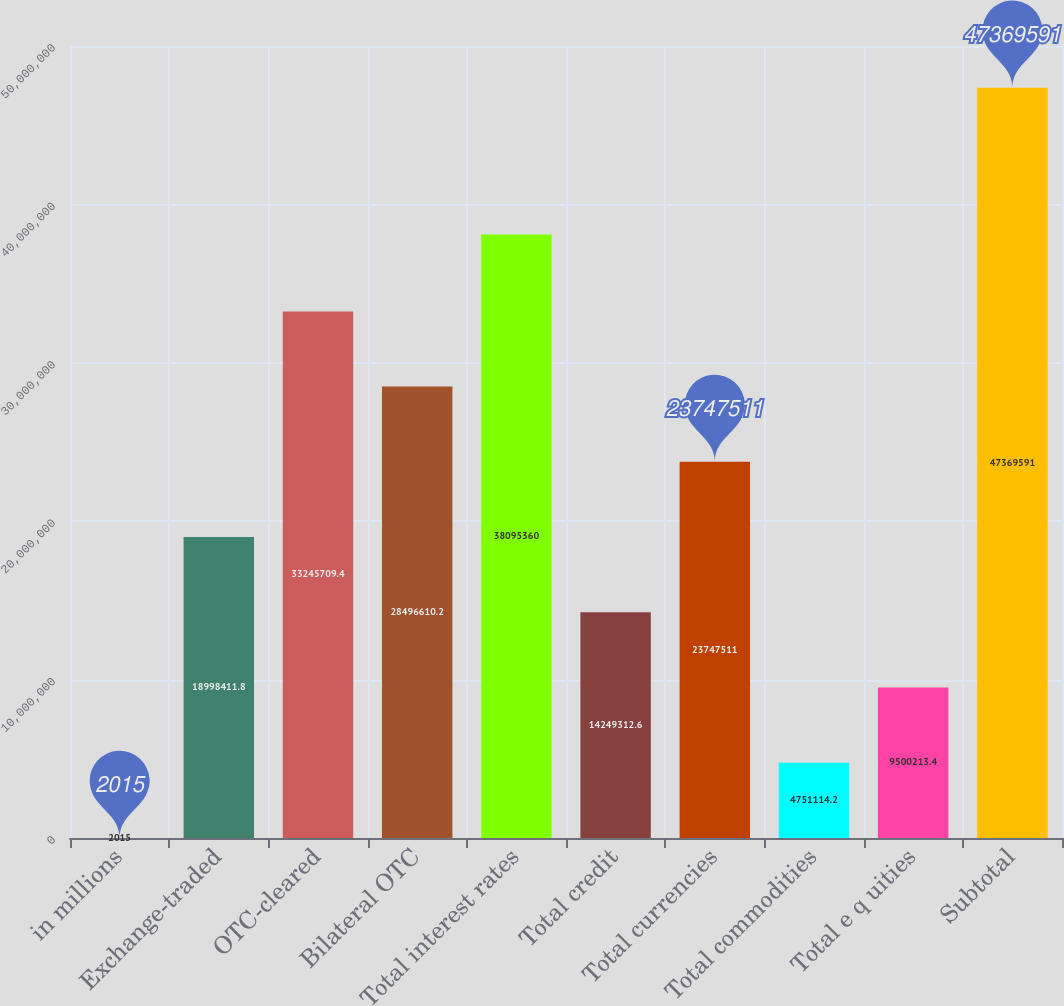<chart> <loc_0><loc_0><loc_500><loc_500><bar_chart><fcel>in millions<fcel>Exchange-traded<fcel>OTC-cleared<fcel>Bilateral OTC<fcel>Total interest rates<fcel>Total credit<fcel>Total currencies<fcel>Total commodities<fcel>Total e q uities<fcel>Subtotal<nl><fcel>2015<fcel>1.89984e+07<fcel>3.32457e+07<fcel>2.84966e+07<fcel>3.80954e+07<fcel>1.42493e+07<fcel>2.37475e+07<fcel>4.75111e+06<fcel>9.50021e+06<fcel>4.73696e+07<nl></chart> 